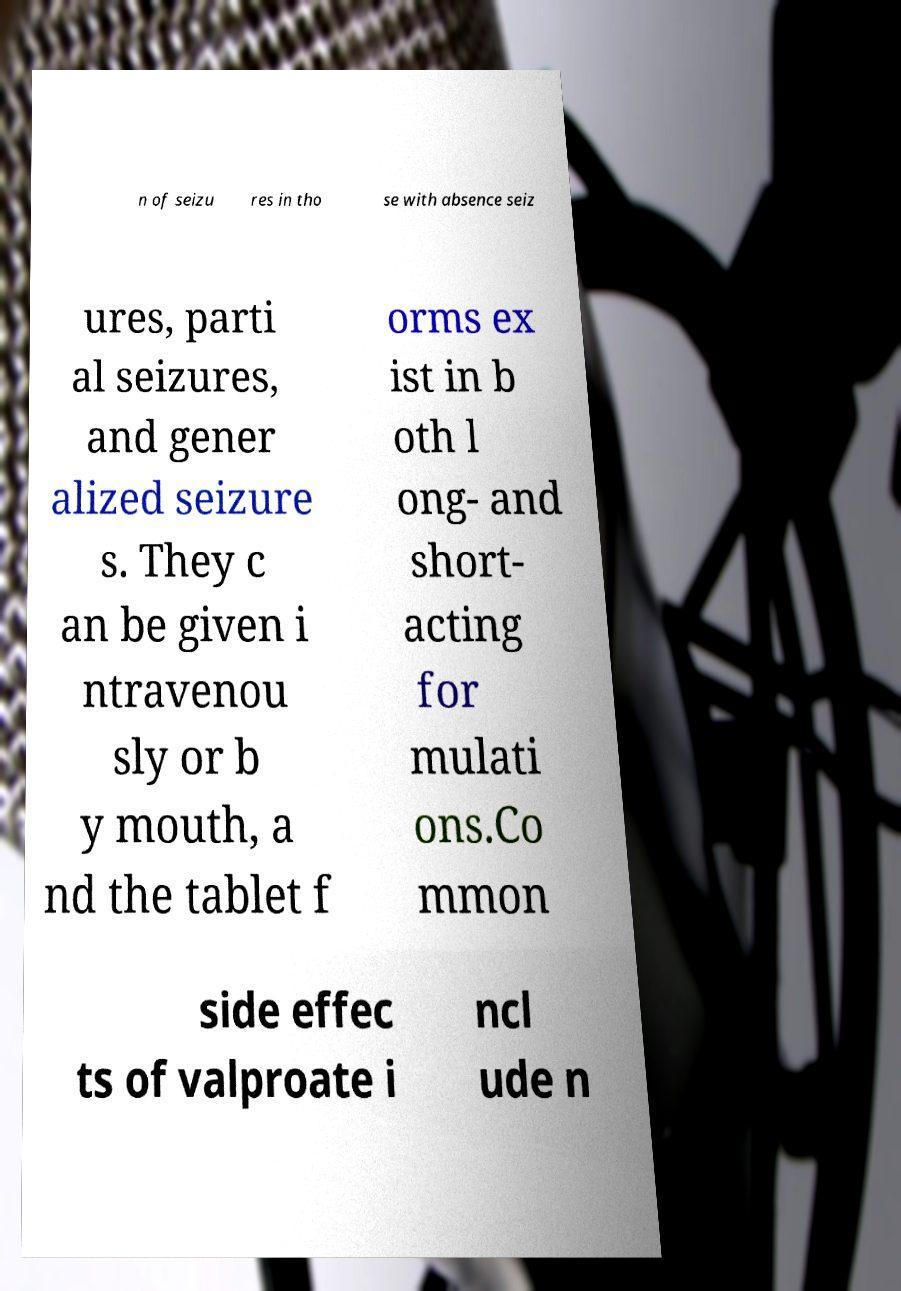I need the written content from this picture converted into text. Can you do that? n of seizu res in tho se with absence seiz ures, parti al seizures, and gener alized seizure s. They c an be given i ntravenou sly or b y mouth, a nd the tablet f orms ex ist in b oth l ong- and short- acting for mulati ons.Co mmon side effec ts of valproate i ncl ude n 